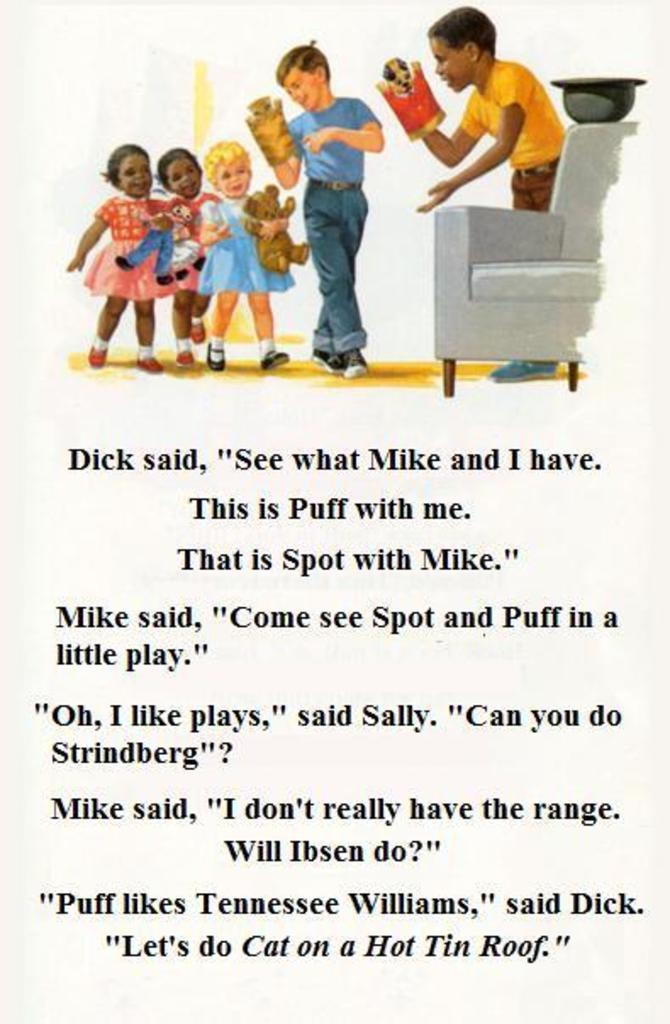What is depicted on the poster in the image? There is a poster with images of kids holding toys in the image. What type of furniture is on the floor in the image? There is a couch on the floor in the image. What can be found on the poster besides the images of kids holding toys? There is text on the poster. How much tax is being paid on the glass in the image? A: There is no glass or mention of tax in the image. Is there any dirt visible on the poster in the image? There is no dirt visible on the poster in the image. 